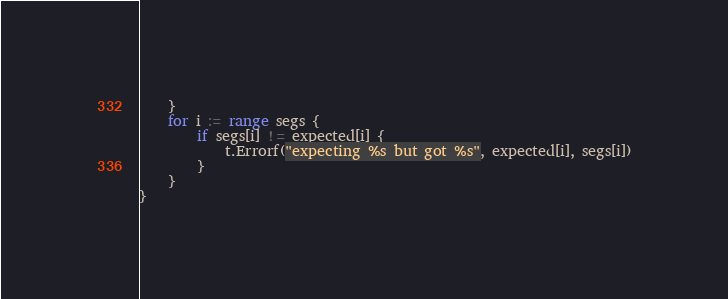<code> <loc_0><loc_0><loc_500><loc_500><_Go_>	}
	for i := range segs {
		if segs[i] != expected[i] {
			t.Errorf("expecting %s but got %s", expected[i], segs[i])
		}
	}
}
</code> 